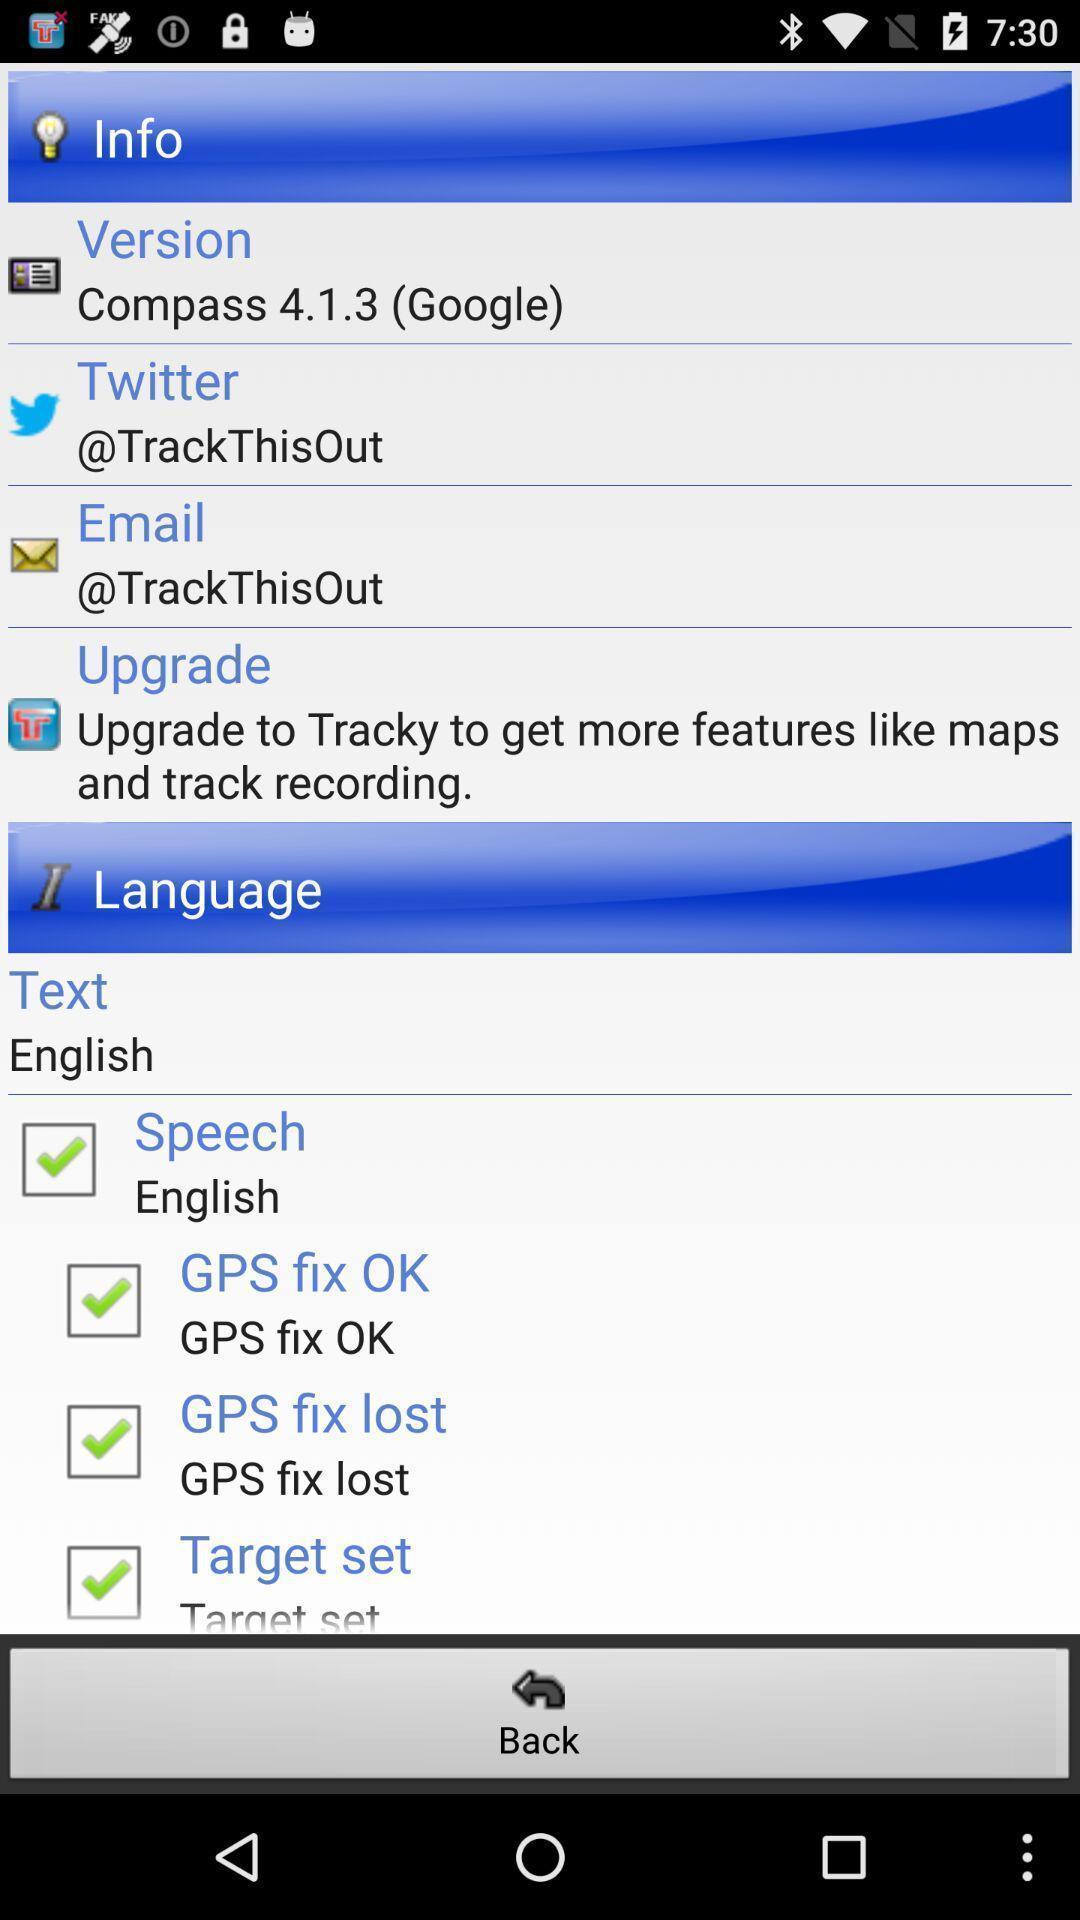Please provide a description for this image. Screen displaying information and language settings. 